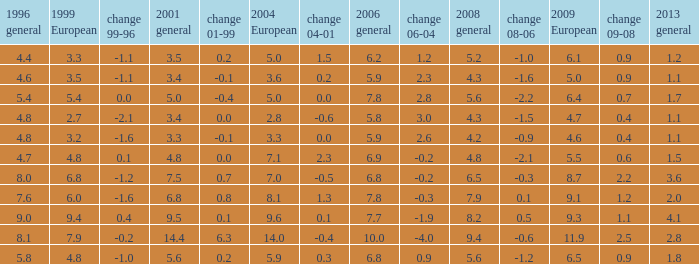What is the average value for general 2001 with more than 4.8 in 1999 European, 7.7 in 2006 general, and more than 9 in 1996 general? None. 